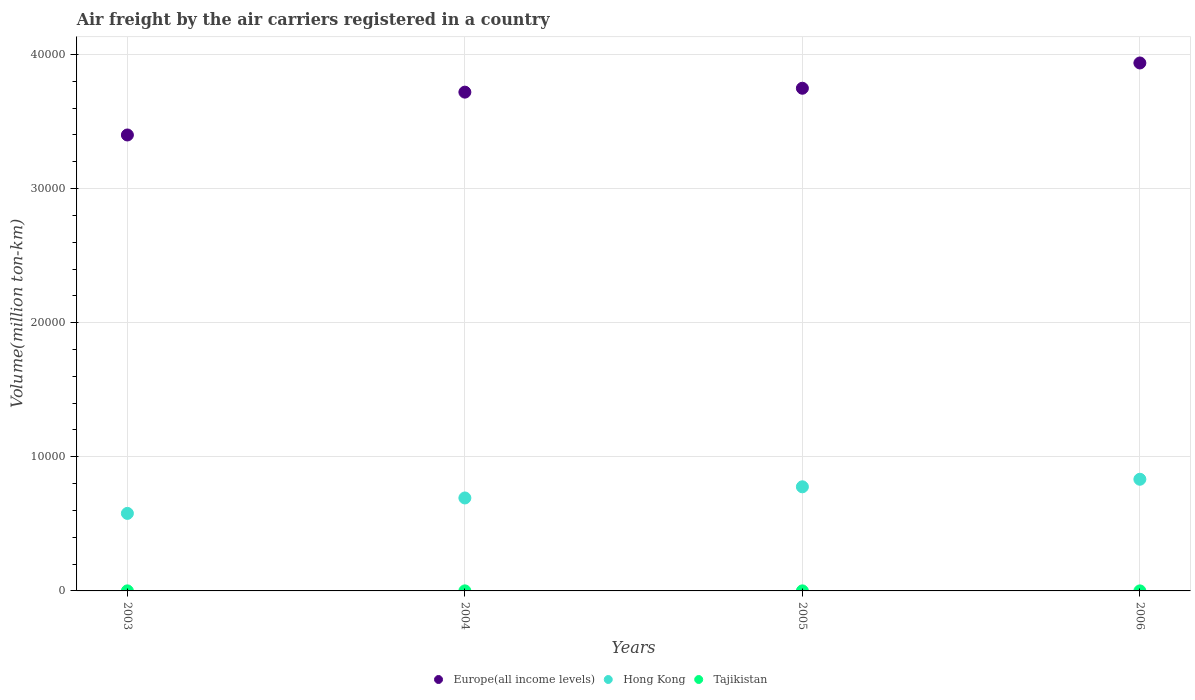How many different coloured dotlines are there?
Provide a succinct answer. 3. Is the number of dotlines equal to the number of legend labels?
Provide a succinct answer. Yes. What is the volume of the air carriers in Europe(all income levels) in 2006?
Your answer should be very brief. 3.94e+04. Across all years, what is the maximum volume of the air carriers in Hong Kong?
Offer a very short reply. 8325.97. In which year was the volume of the air carriers in Tajikistan maximum?
Ensure brevity in your answer.  2004. In which year was the volume of the air carriers in Europe(all income levels) minimum?
Your answer should be very brief. 2003. What is the total volume of the air carriers in Hong Kong in the graph?
Offer a very short reply. 2.88e+04. What is the difference between the volume of the air carriers in Europe(all income levels) in 2004 and that in 2005?
Provide a short and direct response. -290.25. What is the difference between the volume of the air carriers in Hong Kong in 2003 and the volume of the air carriers in Tajikistan in 2005?
Keep it short and to the point. 5777.05. What is the average volume of the air carriers in Hong Kong per year?
Make the answer very short. 7200.56. In the year 2006, what is the difference between the volume of the air carriers in Hong Kong and volume of the air carriers in Tajikistan?
Provide a short and direct response. 8323.57. In how many years, is the volume of the air carriers in Tajikistan greater than 26000 million ton-km?
Provide a short and direct response. 0. What is the ratio of the volume of the air carriers in Europe(all income levels) in 2003 to that in 2004?
Provide a succinct answer. 0.91. Is the volume of the air carriers in Tajikistan in 2003 less than that in 2005?
Give a very brief answer. No. What is the difference between the highest and the second highest volume of the air carriers in Hong Kong?
Offer a very short reply. 562.1. What is the difference between the highest and the lowest volume of the air carriers in Tajikistan?
Provide a succinct answer. 1.7. Does the volume of the air carriers in Europe(all income levels) monotonically increase over the years?
Your response must be concise. Yes. How many dotlines are there?
Provide a succinct answer. 3. Does the graph contain grids?
Your answer should be very brief. Yes. Where does the legend appear in the graph?
Offer a terse response. Bottom center. How many legend labels are there?
Ensure brevity in your answer.  3. How are the legend labels stacked?
Your answer should be very brief. Horizontal. What is the title of the graph?
Your response must be concise. Air freight by the air carriers registered in a country. Does "Timor-Leste" appear as one of the legend labels in the graph?
Provide a short and direct response. No. What is the label or title of the X-axis?
Your answer should be compact. Years. What is the label or title of the Y-axis?
Offer a very short reply. Volume(million ton-km). What is the Volume(million ton-km) in Europe(all income levels) in 2003?
Your response must be concise. 3.40e+04. What is the Volume(million ton-km) in Hong Kong in 2003?
Keep it short and to the point. 5780.75. What is the Volume(million ton-km) of Europe(all income levels) in 2004?
Provide a short and direct response. 3.72e+04. What is the Volume(million ton-km) in Hong Kong in 2004?
Provide a succinct answer. 6931.63. What is the Volume(million ton-km) in Tajikistan in 2004?
Give a very brief answer. 4.1. What is the Volume(million ton-km) in Europe(all income levels) in 2005?
Your answer should be compact. 3.75e+04. What is the Volume(million ton-km) of Hong Kong in 2005?
Your answer should be compact. 7763.87. What is the Volume(million ton-km) of Tajikistan in 2005?
Your answer should be compact. 3.7. What is the Volume(million ton-km) of Europe(all income levels) in 2006?
Provide a short and direct response. 3.94e+04. What is the Volume(million ton-km) of Hong Kong in 2006?
Provide a short and direct response. 8325.97. What is the Volume(million ton-km) of Tajikistan in 2006?
Offer a terse response. 2.4. Across all years, what is the maximum Volume(million ton-km) of Europe(all income levels)?
Ensure brevity in your answer.  3.94e+04. Across all years, what is the maximum Volume(million ton-km) of Hong Kong?
Make the answer very short. 8325.97. Across all years, what is the minimum Volume(million ton-km) in Europe(all income levels)?
Your answer should be compact. 3.40e+04. Across all years, what is the minimum Volume(million ton-km) in Hong Kong?
Provide a short and direct response. 5780.75. What is the total Volume(million ton-km) in Europe(all income levels) in the graph?
Provide a short and direct response. 1.48e+05. What is the total Volume(million ton-km) of Hong Kong in the graph?
Offer a very short reply. 2.88e+04. What is the total Volume(million ton-km) in Tajikistan in the graph?
Offer a very short reply. 14. What is the difference between the Volume(million ton-km) in Europe(all income levels) in 2003 and that in 2004?
Provide a short and direct response. -3194.21. What is the difference between the Volume(million ton-km) in Hong Kong in 2003 and that in 2004?
Your answer should be very brief. -1150.88. What is the difference between the Volume(million ton-km) in Tajikistan in 2003 and that in 2004?
Your response must be concise. -0.3. What is the difference between the Volume(million ton-km) of Europe(all income levels) in 2003 and that in 2005?
Your answer should be very brief. -3484.46. What is the difference between the Volume(million ton-km) of Hong Kong in 2003 and that in 2005?
Your answer should be compact. -1983.12. What is the difference between the Volume(million ton-km) of Tajikistan in 2003 and that in 2005?
Offer a terse response. 0.1. What is the difference between the Volume(million ton-km) of Europe(all income levels) in 2003 and that in 2006?
Provide a succinct answer. -5369.25. What is the difference between the Volume(million ton-km) in Hong Kong in 2003 and that in 2006?
Provide a short and direct response. -2545.22. What is the difference between the Volume(million ton-km) of Europe(all income levels) in 2004 and that in 2005?
Your answer should be compact. -290.25. What is the difference between the Volume(million ton-km) in Hong Kong in 2004 and that in 2005?
Your answer should be compact. -832.24. What is the difference between the Volume(million ton-km) of Europe(all income levels) in 2004 and that in 2006?
Give a very brief answer. -2175.04. What is the difference between the Volume(million ton-km) of Hong Kong in 2004 and that in 2006?
Make the answer very short. -1394.34. What is the difference between the Volume(million ton-km) of Europe(all income levels) in 2005 and that in 2006?
Give a very brief answer. -1884.79. What is the difference between the Volume(million ton-km) in Hong Kong in 2005 and that in 2006?
Make the answer very short. -562.1. What is the difference between the Volume(million ton-km) of Tajikistan in 2005 and that in 2006?
Make the answer very short. 1.3. What is the difference between the Volume(million ton-km) in Europe(all income levels) in 2003 and the Volume(million ton-km) in Hong Kong in 2004?
Ensure brevity in your answer.  2.71e+04. What is the difference between the Volume(million ton-km) of Europe(all income levels) in 2003 and the Volume(million ton-km) of Tajikistan in 2004?
Ensure brevity in your answer.  3.40e+04. What is the difference between the Volume(million ton-km) in Hong Kong in 2003 and the Volume(million ton-km) in Tajikistan in 2004?
Provide a succinct answer. 5776.65. What is the difference between the Volume(million ton-km) in Europe(all income levels) in 2003 and the Volume(million ton-km) in Hong Kong in 2005?
Your response must be concise. 2.62e+04. What is the difference between the Volume(million ton-km) in Europe(all income levels) in 2003 and the Volume(million ton-km) in Tajikistan in 2005?
Ensure brevity in your answer.  3.40e+04. What is the difference between the Volume(million ton-km) in Hong Kong in 2003 and the Volume(million ton-km) in Tajikistan in 2005?
Ensure brevity in your answer.  5777.05. What is the difference between the Volume(million ton-km) in Europe(all income levels) in 2003 and the Volume(million ton-km) in Hong Kong in 2006?
Provide a short and direct response. 2.57e+04. What is the difference between the Volume(million ton-km) of Europe(all income levels) in 2003 and the Volume(million ton-km) of Tajikistan in 2006?
Offer a very short reply. 3.40e+04. What is the difference between the Volume(million ton-km) of Hong Kong in 2003 and the Volume(million ton-km) of Tajikistan in 2006?
Provide a short and direct response. 5778.35. What is the difference between the Volume(million ton-km) in Europe(all income levels) in 2004 and the Volume(million ton-km) in Hong Kong in 2005?
Ensure brevity in your answer.  2.94e+04. What is the difference between the Volume(million ton-km) of Europe(all income levels) in 2004 and the Volume(million ton-km) of Tajikistan in 2005?
Provide a short and direct response. 3.72e+04. What is the difference between the Volume(million ton-km) in Hong Kong in 2004 and the Volume(million ton-km) in Tajikistan in 2005?
Provide a short and direct response. 6927.93. What is the difference between the Volume(million ton-km) of Europe(all income levels) in 2004 and the Volume(million ton-km) of Hong Kong in 2006?
Offer a terse response. 2.89e+04. What is the difference between the Volume(million ton-km) in Europe(all income levels) in 2004 and the Volume(million ton-km) in Tajikistan in 2006?
Keep it short and to the point. 3.72e+04. What is the difference between the Volume(million ton-km) in Hong Kong in 2004 and the Volume(million ton-km) in Tajikistan in 2006?
Offer a terse response. 6929.23. What is the difference between the Volume(million ton-km) in Europe(all income levels) in 2005 and the Volume(million ton-km) in Hong Kong in 2006?
Ensure brevity in your answer.  2.92e+04. What is the difference between the Volume(million ton-km) of Europe(all income levels) in 2005 and the Volume(million ton-km) of Tajikistan in 2006?
Offer a very short reply. 3.75e+04. What is the difference between the Volume(million ton-km) in Hong Kong in 2005 and the Volume(million ton-km) in Tajikistan in 2006?
Give a very brief answer. 7761.47. What is the average Volume(million ton-km) in Europe(all income levels) per year?
Your response must be concise. 3.70e+04. What is the average Volume(million ton-km) in Hong Kong per year?
Your answer should be compact. 7200.56. In the year 2003, what is the difference between the Volume(million ton-km) in Europe(all income levels) and Volume(million ton-km) in Hong Kong?
Ensure brevity in your answer.  2.82e+04. In the year 2003, what is the difference between the Volume(million ton-km) in Europe(all income levels) and Volume(million ton-km) in Tajikistan?
Provide a short and direct response. 3.40e+04. In the year 2003, what is the difference between the Volume(million ton-km) of Hong Kong and Volume(million ton-km) of Tajikistan?
Offer a terse response. 5776.95. In the year 2004, what is the difference between the Volume(million ton-km) of Europe(all income levels) and Volume(million ton-km) of Hong Kong?
Offer a terse response. 3.03e+04. In the year 2004, what is the difference between the Volume(million ton-km) of Europe(all income levels) and Volume(million ton-km) of Tajikistan?
Offer a very short reply. 3.72e+04. In the year 2004, what is the difference between the Volume(million ton-km) of Hong Kong and Volume(million ton-km) of Tajikistan?
Your response must be concise. 6927.53. In the year 2005, what is the difference between the Volume(million ton-km) of Europe(all income levels) and Volume(million ton-km) of Hong Kong?
Your response must be concise. 2.97e+04. In the year 2005, what is the difference between the Volume(million ton-km) in Europe(all income levels) and Volume(million ton-km) in Tajikistan?
Offer a very short reply. 3.75e+04. In the year 2005, what is the difference between the Volume(million ton-km) in Hong Kong and Volume(million ton-km) in Tajikistan?
Provide a short and direct response. 7760.17. In the year 2006, what is the difference between the Volume(million ton-km) in Europe(all income levels) and Volume(million ton-km) in Hong Kong?
Provide a short and direct response. 3.10e+04. In the year 2006, what is the difference between the Volume(million ton-km) in Europe(all income levels) and Volume(million ton-km) in Tajikistan?
Your response must be concise. 3.94e+04. In the year 2006, what is the difference between the Volume(million ton-km) of Hong Kong and Volume(million ton-km) of Tajikistan?
Provide a succinct answer. 8323.57. What is the ratio of the Volume(million ton-km) of Europe(all income levels) in 2003 to that in 2004?
Ensure brevity in your answer.  0.91. What is the ratio of the Volume(million ton-km) in Hong Kong in 2003 to that in 2004?
Give a very brief answer. 0.83. What is the ratio of the Volume(million ton-km) of Tajikistan in 2003 to that in 2004?
Your answer should be compact. 0.93. What is the ratio of the Volume(million ton-km) in Europe(all income levels) in 2003 to that in 2005?
Provide a short and direct response. 0.91. What is the ratio of the Volume(million ton-km) of Hong Kong in 2003 to that in 2005?
Make the answer very short. 0.74. What is the ratio of the Volume(million ton-km) in Tajikistan in 2003 to that in 2005?
Give a very brief answer. 1.03. What is the ratio of the Volume(million ton-km) in Europe(all income levels) in 2003 to that in 2006?
Provide a short and direct response. 0.86. What is the ratio of the Volume(million ton-km) in Hong Kong in 2003 to that in 2006?
Keep it short and to the point. 0.69. What is the ratio of the Volume(million ton-km) in Tajikistan in 2003 to that in 2006?
Your answer should be very brief. 1.58. What is the ratio of the Volume(million ton-km) in Hong Kong in 2004 to that in 2005?
Keep it short and to the point. 0.89. What is the ratio of the Volume(million ton-km) of Tajikistan in 2004 to that in 2005?
Your answer should be compact. 1.11. What is the ratio of the Volume(million ton-km) in Europe(all income levels) in 2004 to that in 2006?
Make the answer very short. 0.94. What is the ratio of the Volume(million ton-km) of Hong Kong in 2004 to that in 2006?
Provide a short and direct response. 0.83. What is the ratio of the Volume(million ton-km) of Tajikistan in 2004 to that in 2006?
Give a very brief answer. 1.71. What is the ratio of the Volume(million ton-km) in Europe(all income levels) in 2005 to that in 2006?
Your answer should be very brief. 0.95. What is the ratio of the Volume(million ton-km) in Hong Kong in 2005 to that in 2006?
Ensure brevity in your answer.  0.93. What is the ratio of the Volume(million ton-km) of Tajikistan in 2005 to that in 2006?
Make the answer very short. 1.54. What is the difference between the highest and the second highest Volume(million ton-km) of Europe(all income levels)?
Ensure brevity in your answer.  1884.79. What is the difference between the highest and the second highest Volume(million ton-km) in Hong Kong?
Offer a very short reply. 562.1. What is the difference between the highest and the lowest Volume(million ton-km) in Europe(all income levels)?
Offer a terse response. 5369.25. What is the difference between the highest and the lowest Volume(million ton-km) in Hong Kong?
Make the answer very short. 2545.22. 